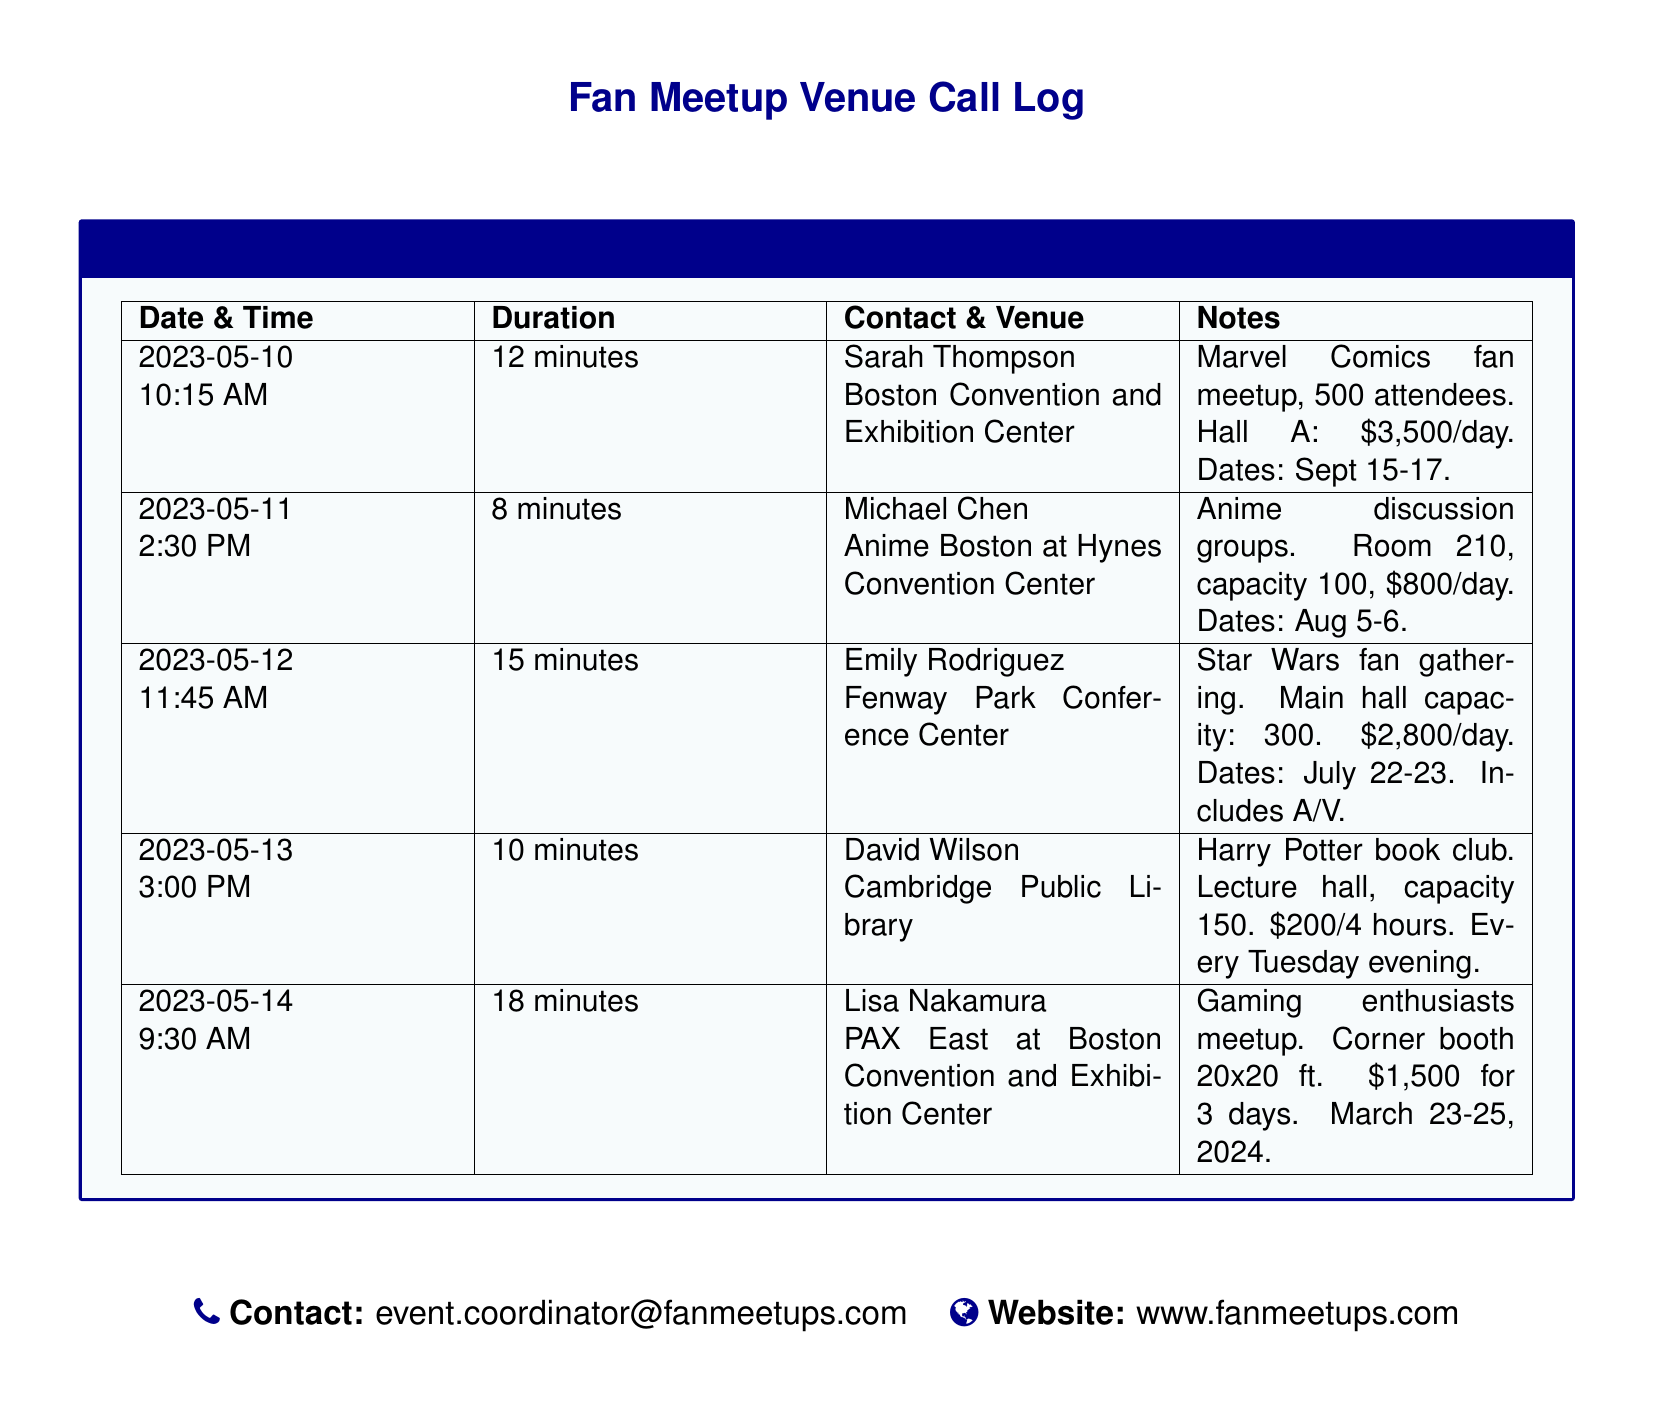What is the date and time of the first call? The document lists the first call on May 10, 2023, at 10:15 AM.
Answer: May 10, 2023, 10:15 AM Who is the contact for the second venue? The second venue is associated with Michael Chen.
Answer: Michael Chen What is the duration of the call with Lisa Nakamura? The duration of the call recorded for Lisa Nakamura is 18 minutes.
Answer: 18 minutes What is the capacity of the lecture hall at the Cambridge Public Library? The capacity of the lecture hall is mentioned as 150.
Answer: 150 What are the dates for the Marvel Comics fan meetup? The dates for the Marvel Comics fan meetup are specified as September 15-17.
Answer: September 15-17 How much does it cost per day to book the main hall at the Fenway Park Conference Center? The cost per day for booking the main hall is $2,800.
Answer: $2,800 What type of event is scheduled for August 5-6 at the Hynes Convention Center? The event scheduled for those dates is related to anime discussion groups.
Answer: Anime discussion groups How many days is the gaming enthusiasts meetup planned for? The gaming enthusiasts meetup is planned for 3 days.
Answer: 3 days What is the email contact for the event coordinator? The email contact is provided as event.coordinator@fanmeetups.com.
Answer: event.coordinator@fanmeetups.com 